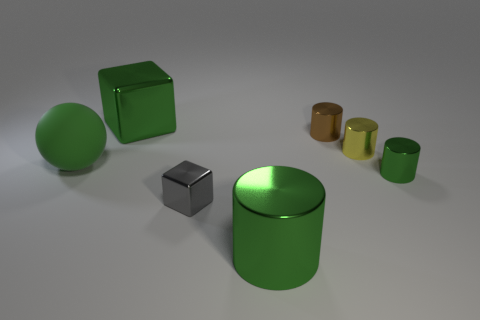What materials do the objects in the image appear to be made of? The objects in the image display a variety of finishes. The large green sphere and the prominent cylinder exhibit a glossy, reflective surface which suggests they might be made of a polished metal or plastic. The gray cube, on the other hand, has a matte finish which could imply a material like stone or frosted glass. 